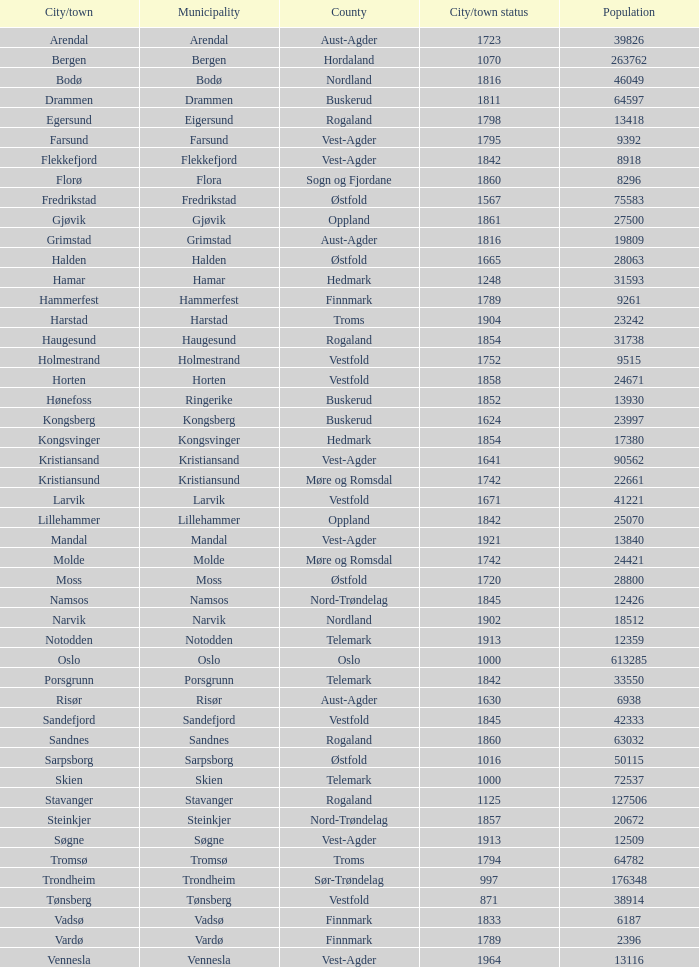In the municipality of horten, what are the various towns or cities situated there? Horten. 